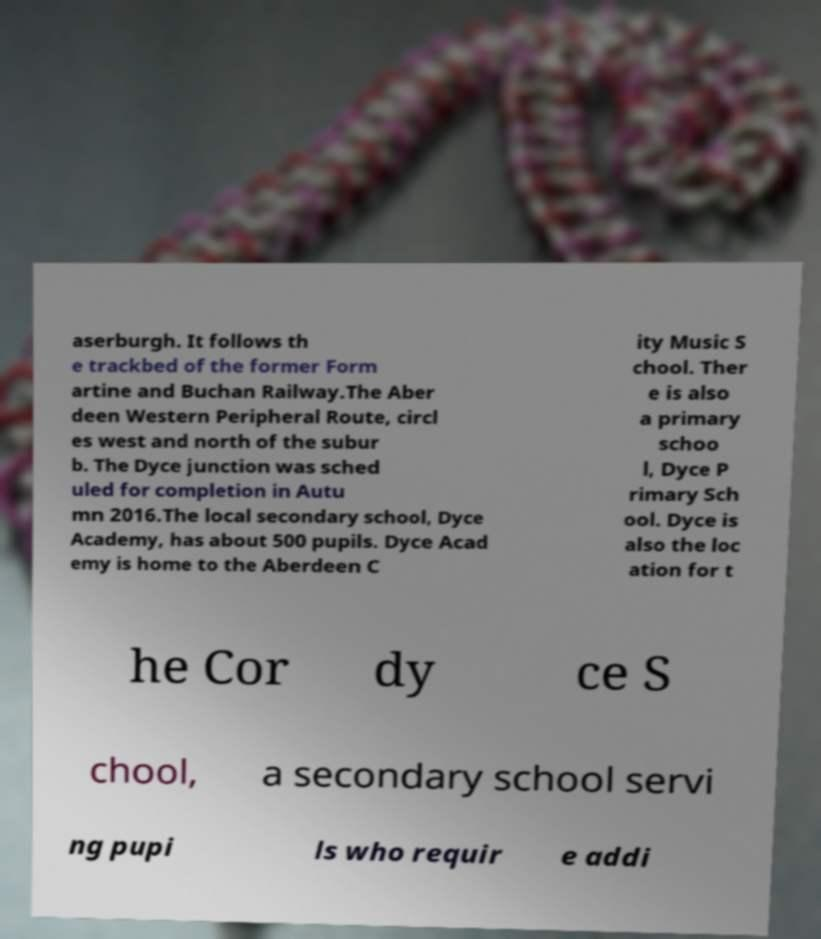Please read and relay the text visible in this image. What does it say? aserburgh. It follows th e trackbed of the former Form artine and Buchan Railway.The Aber deen Western Peripheral Route, circl es west and north of the subur b. The Dyce junction was sched uled for completion in Autu mn 2016.The local secondary school, Dyce Academy, has about 500 pupils. Dyce Acad emy is home to the Aberdeen C ity Music S chool. Ther e is also a primary schoo l, Dyce P rimary Sch ool. Dyce is also the loc ation for t he Cor dy ce S chool, a secondary school servi ng pupi ls who requir e addi 